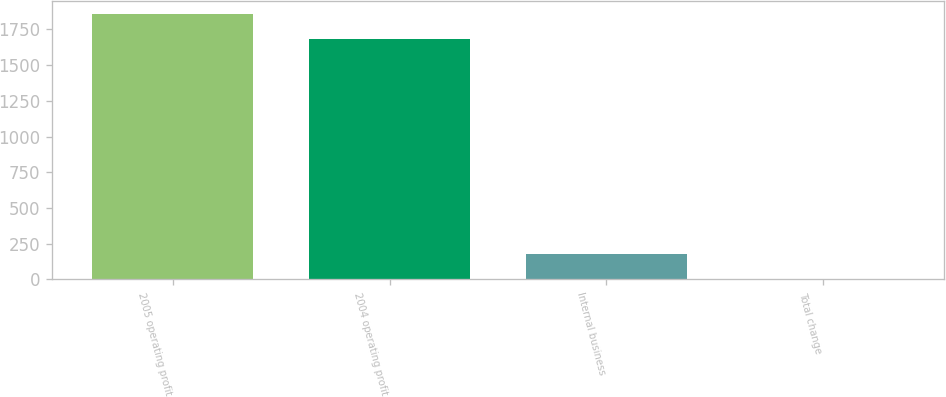<chart> <loc_0><loc_0><loc_500><loc_500><bar_chart><fcel>2005 operating profit<fcel>2004 operating profit<fcel>Internal business<fcel>Total change<nl><fcel>1855.72<fcel>1681.1<fcel>178.72<fcel>4.1<nl></chart> 